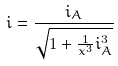Convert formula to latex. <formula><loc_0><loc_0><loc_500><loc_500>i = \frac { i _ { A } } { \sqrt { 1 + \frac { 1 } { x ^ { 3 } } i _ { A } ^ { 3 } } }</formula> 